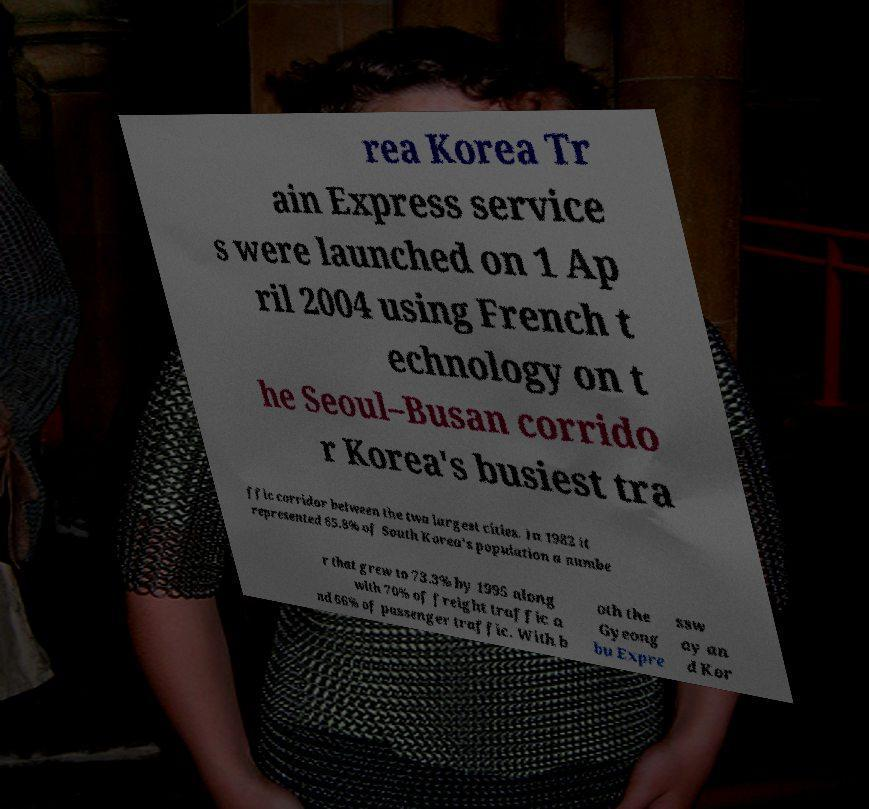There's text embedded in this image that I need extracted. Can you transcribe it verbatim? rea Korea Tr ain Express service s were launched on 1 Ap ril 2004 using French t echnology on t he Seoul–Busan corrido r Korea's busiest tra ffic corridor between the two largest cities. In 1982 it represented 65.8% of South Korea's population a numbe r that grew to 73.3% by 1995 along with 70% of freight traffic a nd 66% of passenger traffic. With b oth the Gyeong bu Expre ssw ay an d Kor 